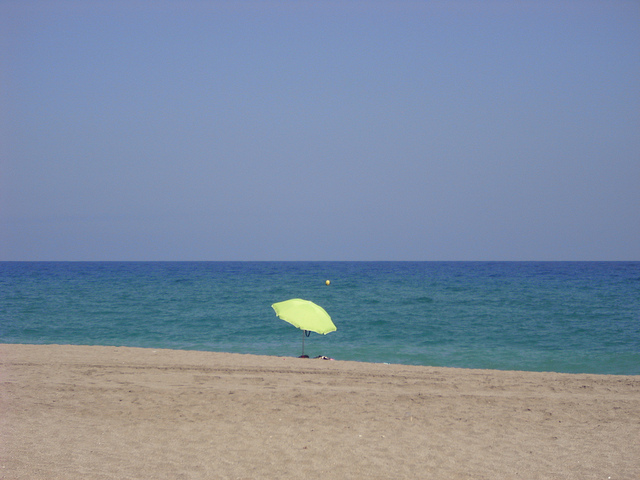What is the object in the middle? The object in the middle of the image is a bright, lemon-green colored umbrella, planted firmly in the sand on a beach. It stands out prominently against the backdrop of a calm blue sea. 